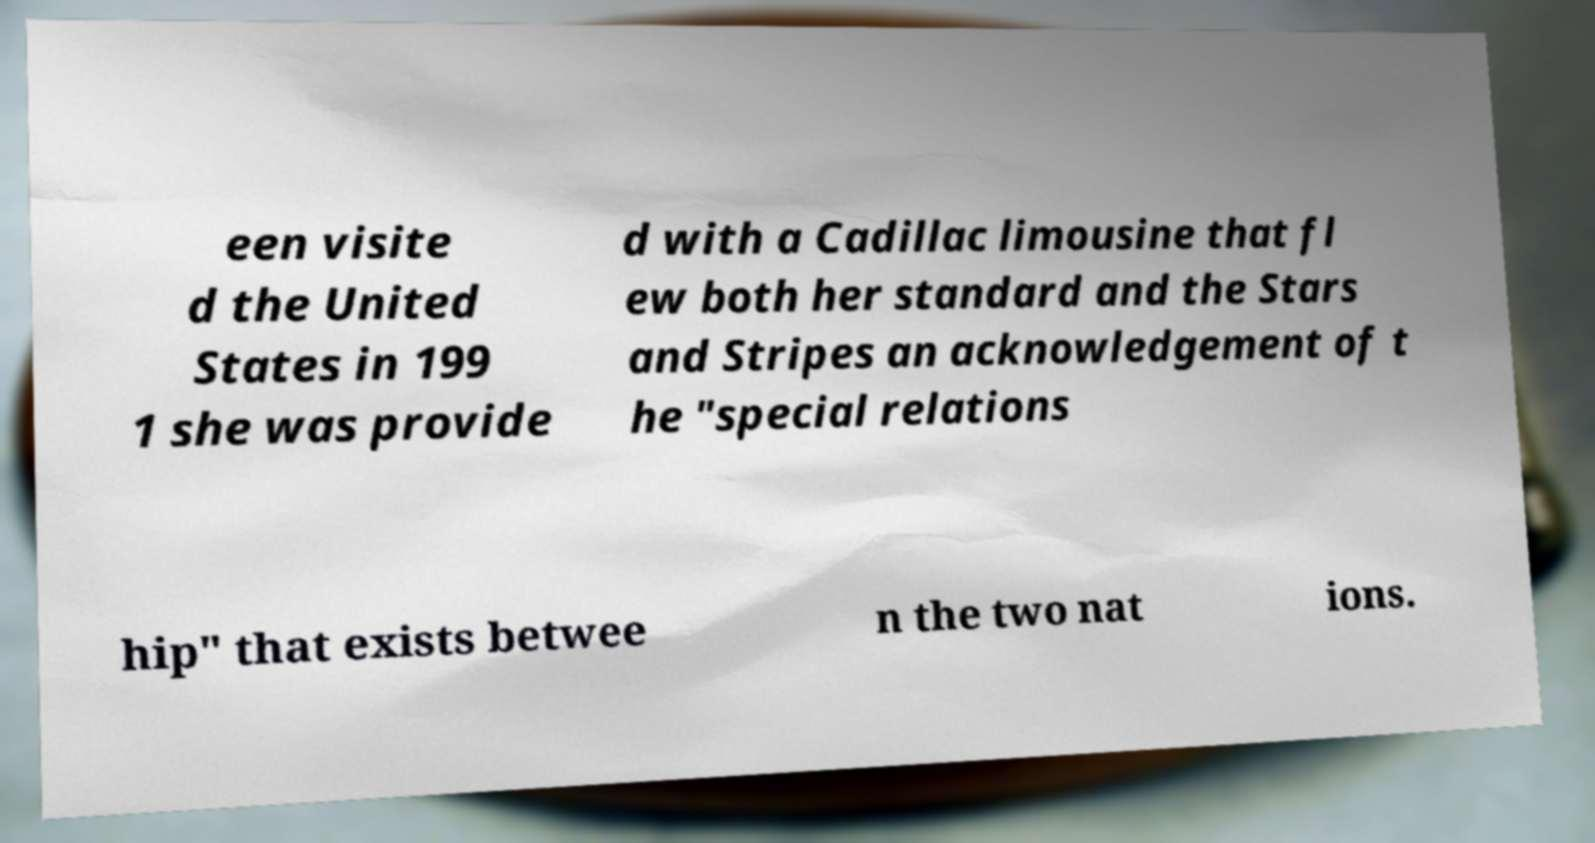Can you read and provide the text displayed in the image?This photo seems to have some interesting text. Can you extract and type it out for me? een visite d the United States in 199 1 she was provide d with a Cadillac limousine that fl ew both her standard and the Stars and Stripes an acknowledgement of t he "special relations hip" that exists betwee n the two nat ions. 